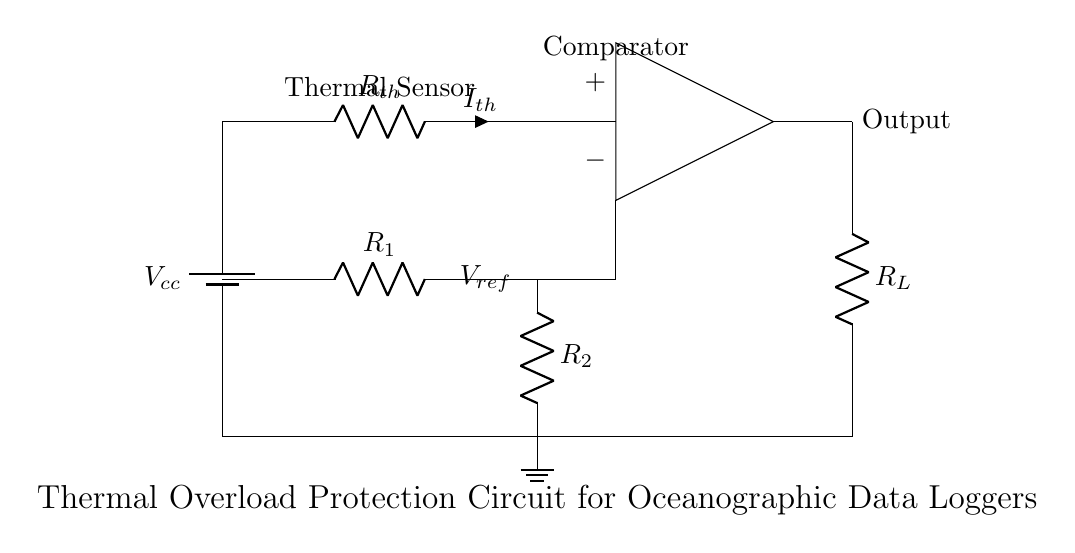what does the symbol at the top left represent? The symbol at the top left is a battery, representing the power supply, labeled as Vcc. It indicates the source of voltage for the circuit.
Answer: battery what type of sensor is present in the circuit? The circuit diagram includes a thermistor, labeled as Rth, which is a temperature-sensitive resistor that changes resistance with temperature.
Answer: thermistor what is the function of the comparator in this circuit? The comparator, shown in the circuit, compares the voltage across the thermistor to a reference voltage, determining if the thermal level exceeds a set threshold, thereby activating the output.
Answer: compare voltages how is the reference voltage created in the circuit? The reference voltage is created using resistors R1 and R2, which form a voltage divider. The divided voltage is then connected to one of the input terminals of the comparator.
Answer: voltage divider describe the role of component RL in the circuit. RL, labeled as the load resistor, is the component that receives the output signal from the comparator, controlling the load based on the thermal condition monitored.
Answer: load resistor what will happen if the temperature exceeds the threshold? If the temperature exceeds the threshold, the comparator will output a signal based on its design, which may toggle RL to disconnect or activate a load, providing overload protection.
Answer: disconnect load which component provides grounding in the circuit? The ground in the circuit is represented by the symbol for ground at the bottom center; it is the common return path for current, ensuring the entire circuit functions correctly.
Answer: ground 